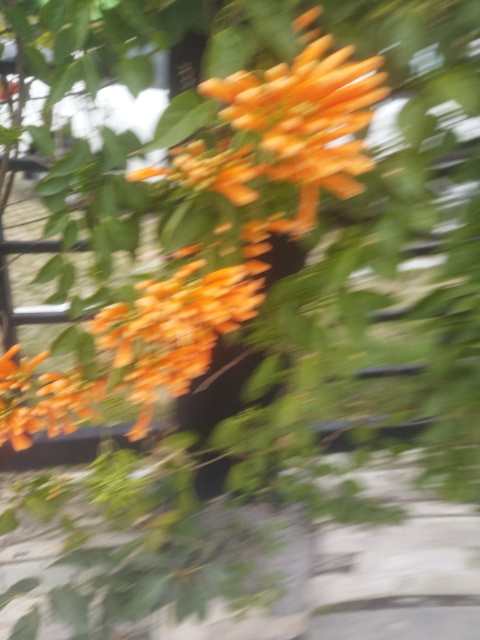How might weather conditions affect the appearance of these flowers? The appearance of these flowers can be significantly influenced by weather conditions. Bright, sunny days can enhance their vibrant orange color, while too much rain might lead to water spots or drooping flowers. Is there a best time of year to photograph these flowers for clearer details? The best time to photograph these flowers for clearer details would be early morning or late afternoon on a sunny day in spring or summer, when the light is softer and the flowers are in full bloom. 